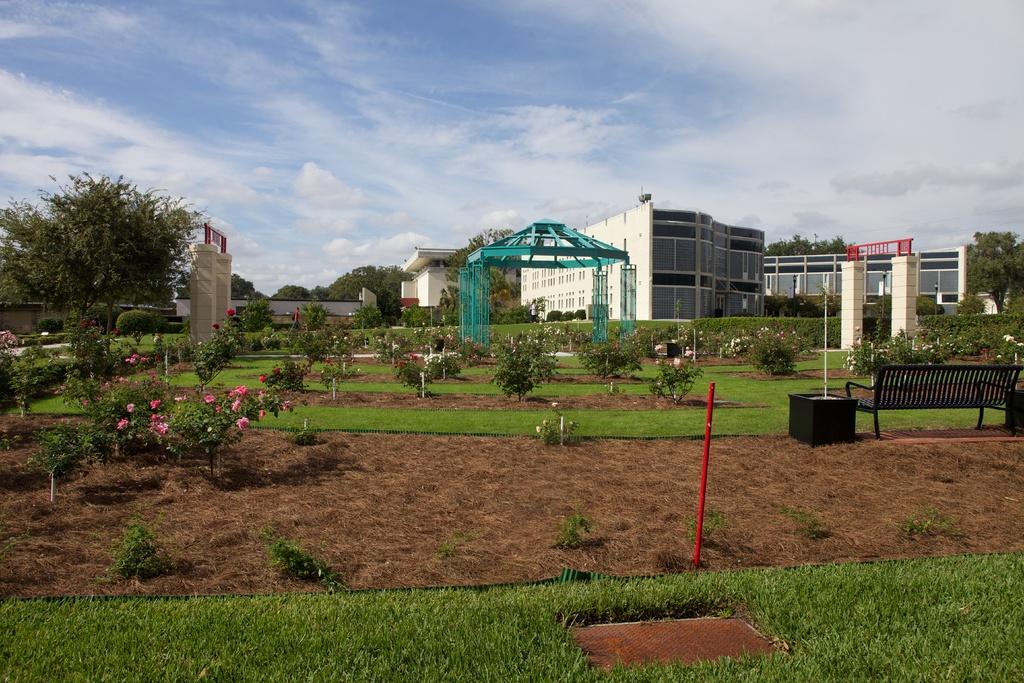Please provide a concise description of this image. In this picture we can see there are plants, poles, a bench, arches, grass, hedges and an iron structure on the ground. Behind the iron structure, there are trees, buildings and the sky. 